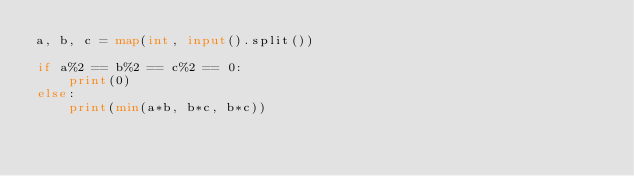<code> <loc_0><loc_0><loc_500><loc_500><_Python_>a, b, c = map(int, input().split())

if a%2 == b%2 == c%2 == 0:
    print(0)
else:
    print(min(a*b, b*c, b*c))</code> 